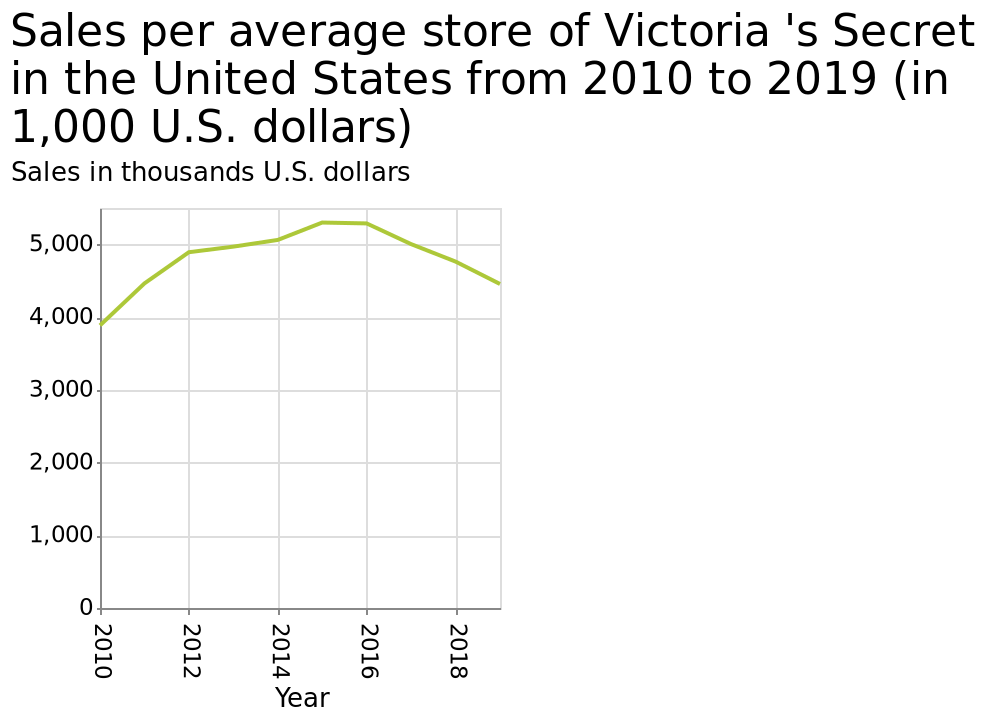<image>
What was the sales per average store from 2015 to 2019? The sales per average store remained at a plateau of above 5000 dollars from 2015 to 2016, and then slowly decreased until it reached around 4500 dollars in 2019. When did the sales per average store start to decrease?  The sales per average store started to decrease after 2016. What is the title of the line graph?  The title of the line graph is "Sales per average store of Victoria's Secret in the United States from 2010 to 2019 (in 1,000 U.S. dollars)." 